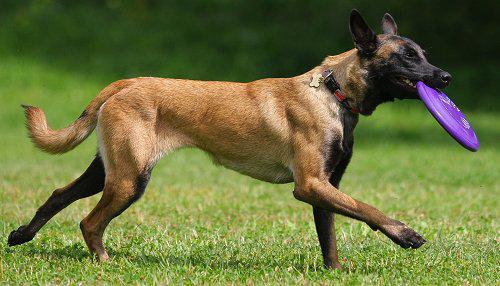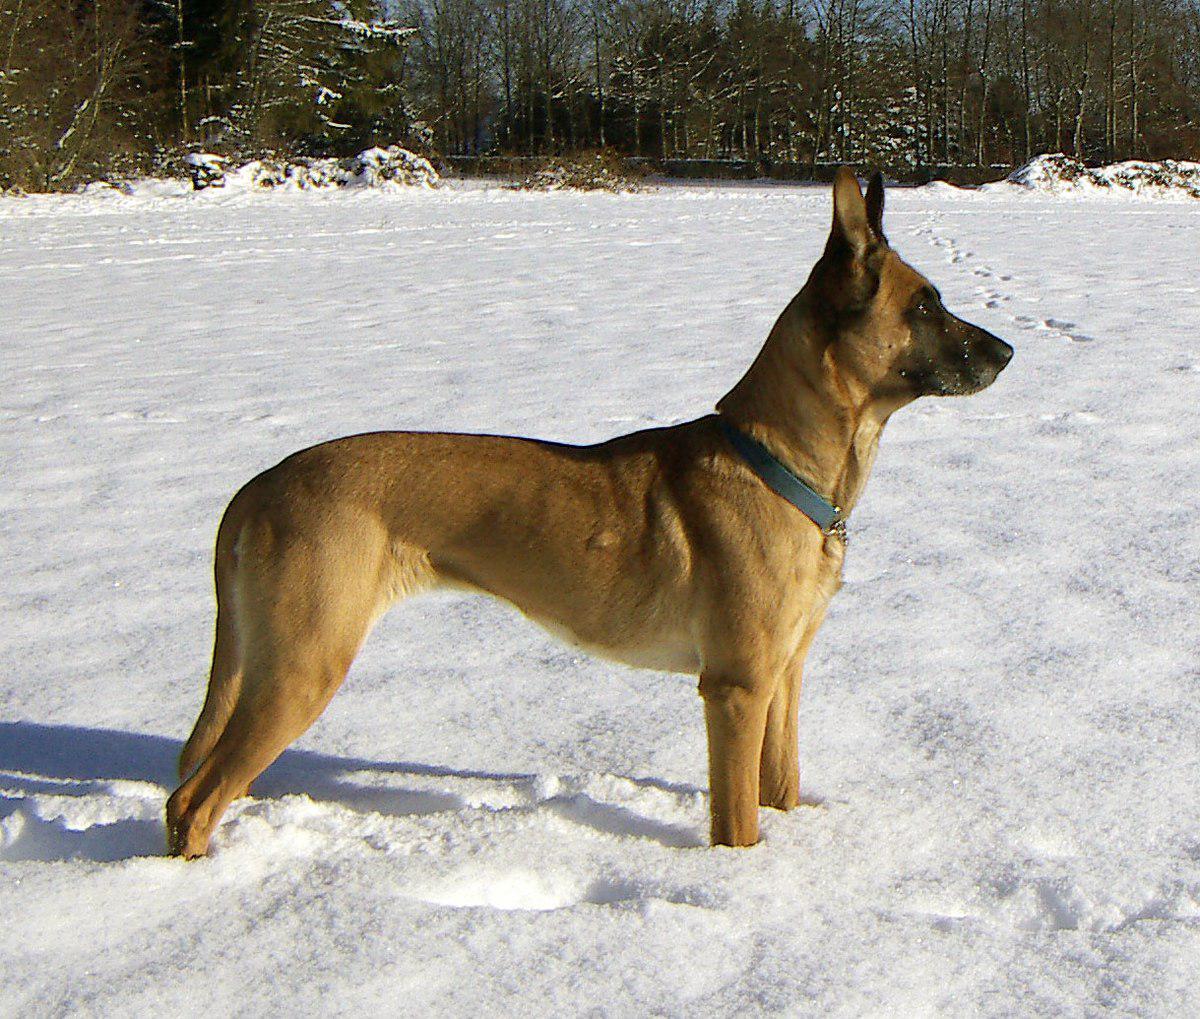The first image is the image on the left, the second image is the image on the right. For the images shown, is this caption "The dogs are looking in the same direction" true? Answer yes or no. Yes. The first image is the image on the left, the second image is the image on the right. For the images displayed, is the sentence "There is at least one dog sitting down" factually correct? Answer yes or no. No. The first image is the image on the left, the second image is the image on the right. Given the left and right images, does the statement "In at least one image, a dog is gripping a toy in its mouth." hold true? Answer yes or no. Yes. The first image is the image on the left, the second image is the image on the right. Analyze the images presented: Is the assertion "The dog in the image on the left is sitting." valid? Answer yes or no. No. The first image is the image on the left, the second image is the image on the right. For the images displayed, is the sentence "There are exactly two German Shepherd dogs and either they both have collars around their neck or neither do." factually correct? Answer yes or no. Yes. 